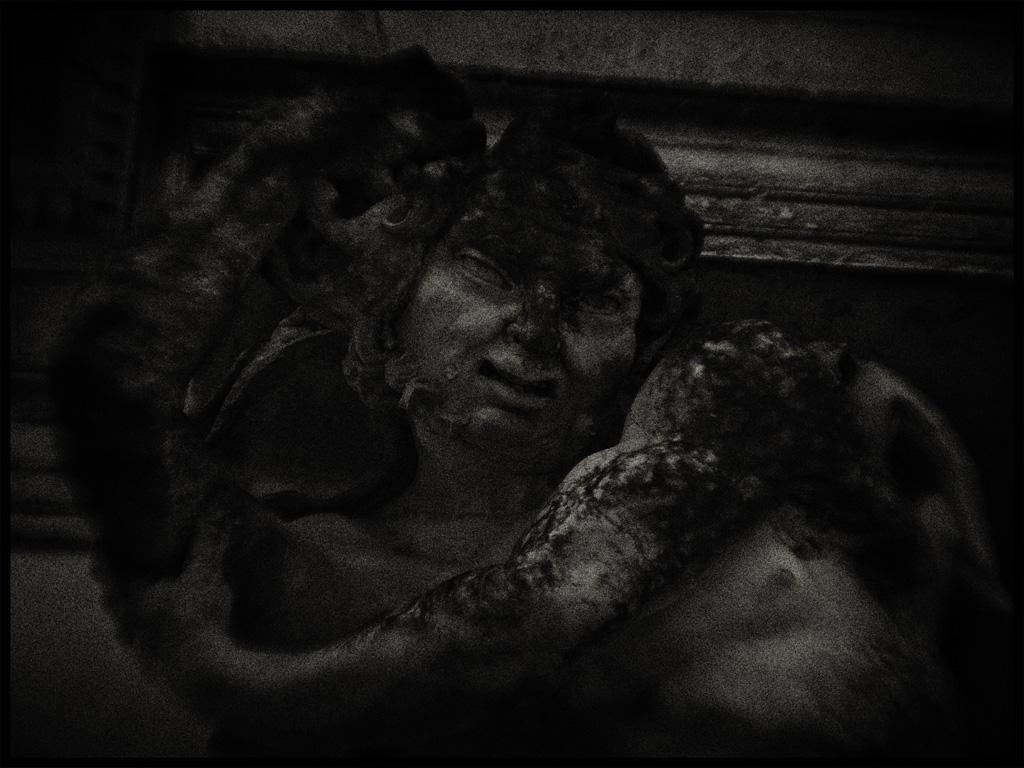How would you summarize this image in a sentence or two? In this black and white image, we can see depiction of a person. 